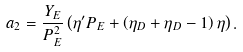Convert formula to latex. <formula><loc_0><loc_0><loc_500><loc_500>a _ { 2 } = \frac { Y _ { E } } { P _ { E } ^ { 2 } } \left ( \eta ^ { \prime } P _ { E } + \left ( \eta _ { D } + \eta _ { D } - 1 \right ) \eta \right ) .</formula> 